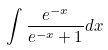<formula> <loc_0><loc_0><loc_500><loc_500>\int \frac { e ^ { - x } } { e ^ { - x } + 1 } d x</formula> 